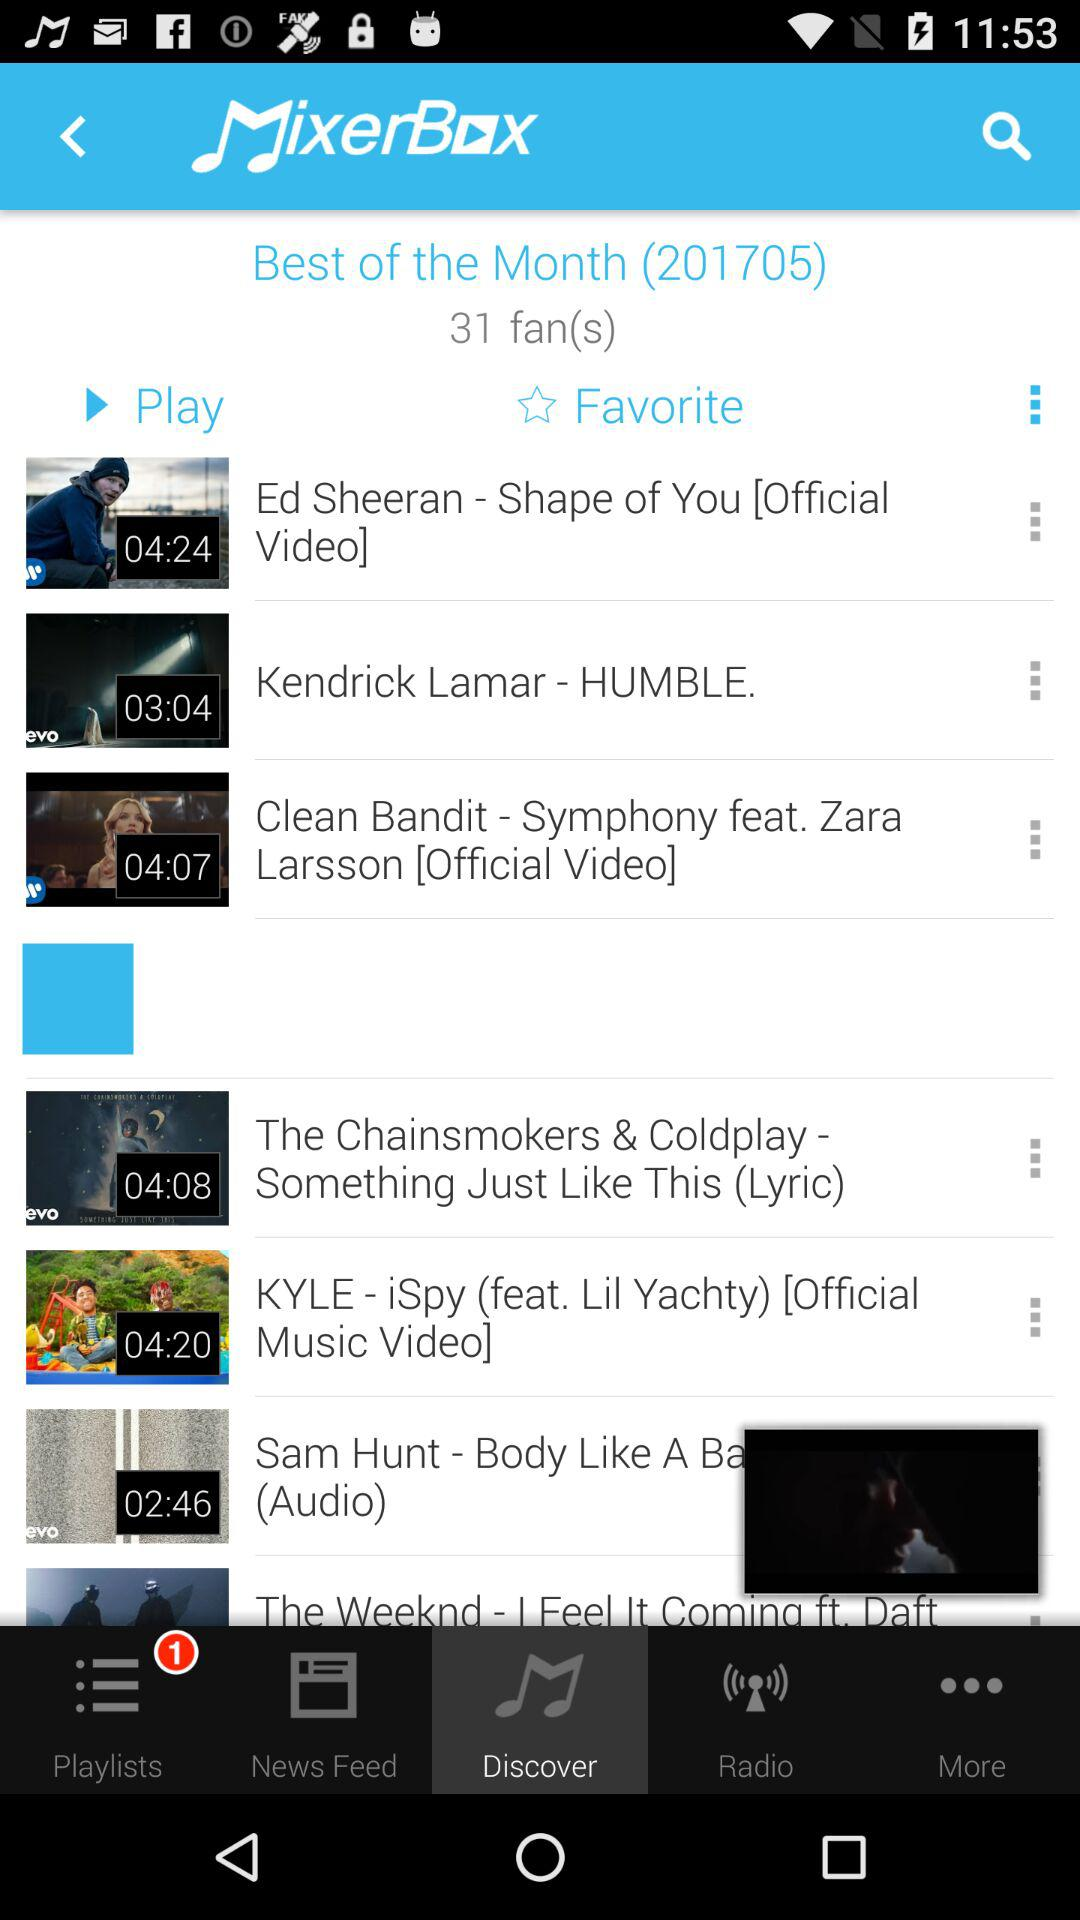What is the name of the application? The name of the application is "MixerBox". 